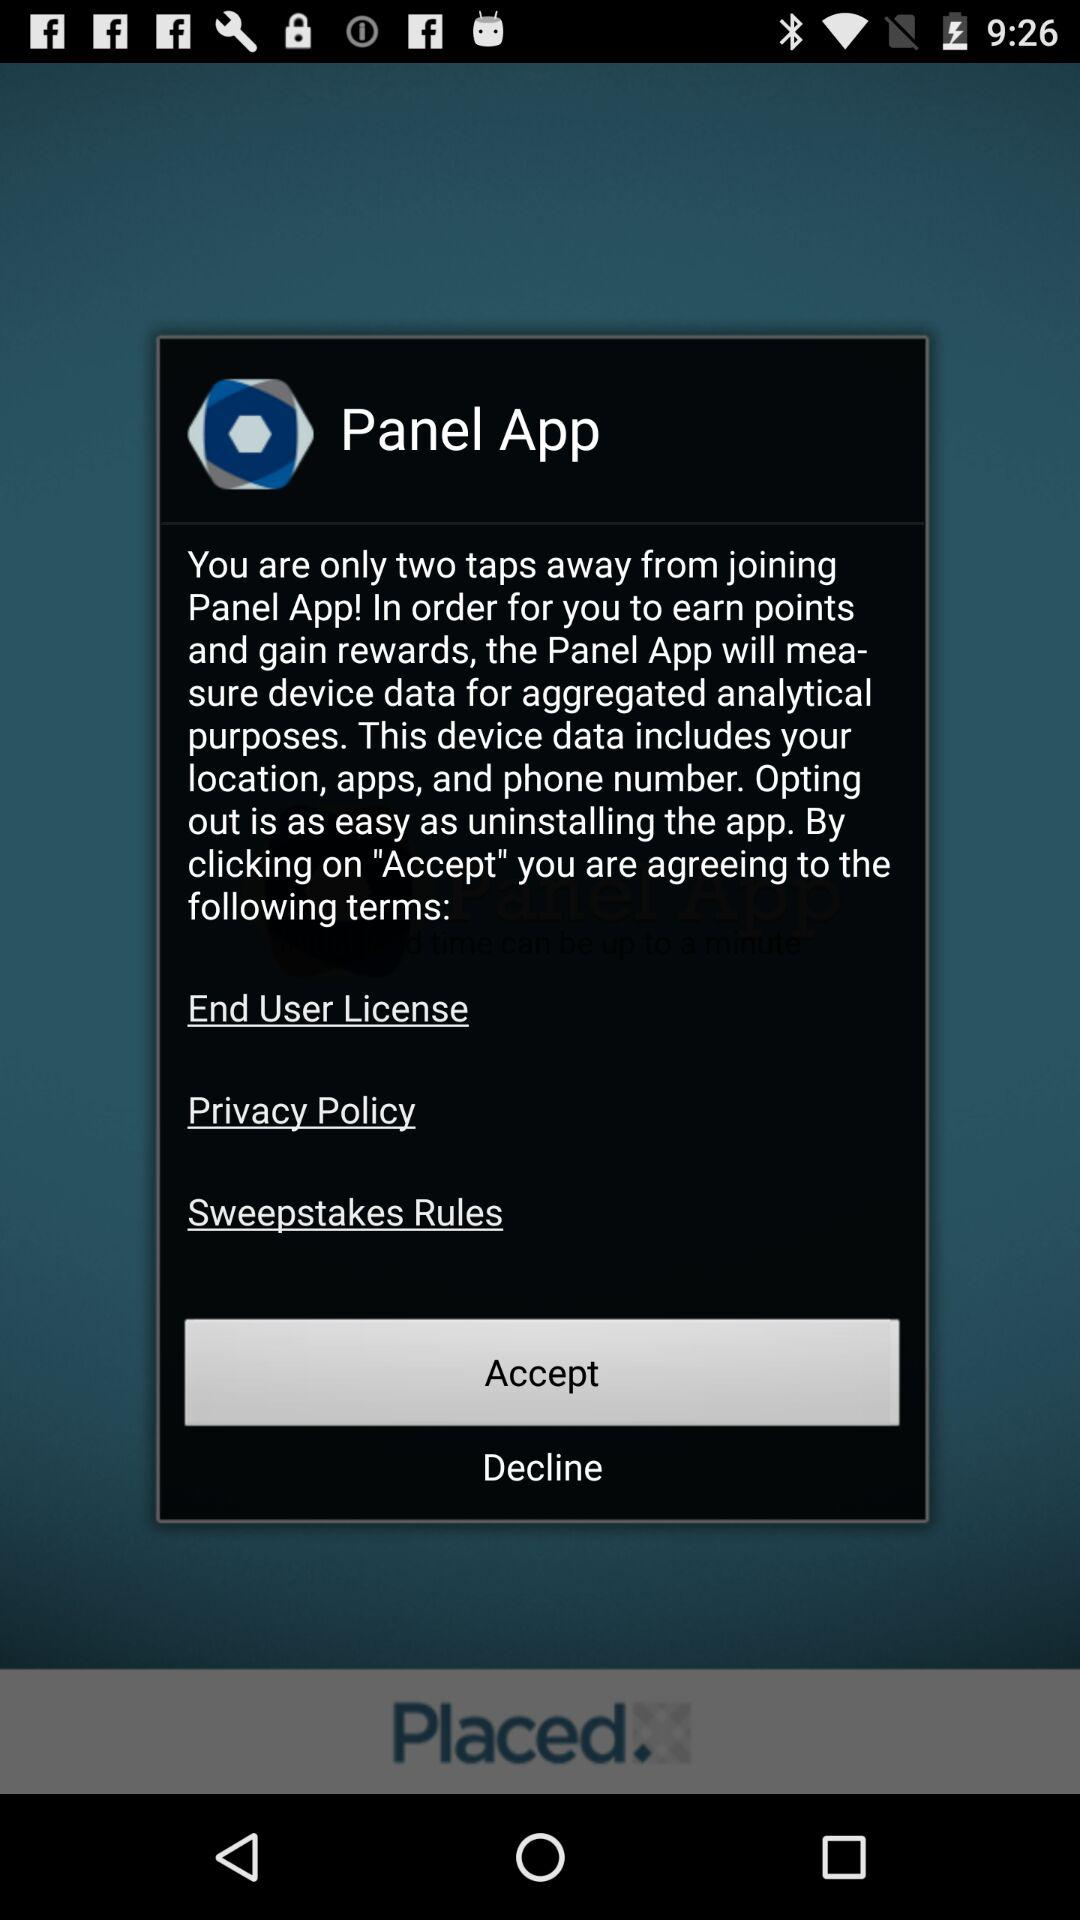What is the name of the application? The name of the application is "Panel App". 